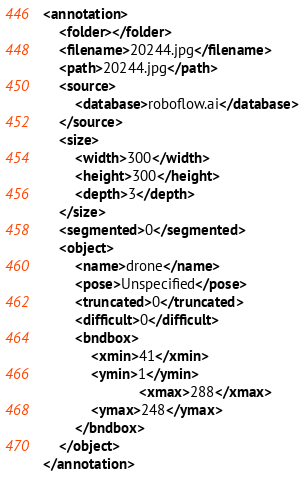Convert code to text. <code><loc_0><loc_0><loc_500><loc_500><_XML_><annotation>
	<folder></folder>
	<filename>20244.jpg</filename>
	<path>20244.jpg</path>
	<source>
		<database>roboflow.ai</database>
	</source>
	<size>
		<width>300</width>
		<height>300</height>
		<depth>3</depth>
	</size>
	<segmented>0</segmented>
	<object>
		<name>drone</name>
		<pose>Unspecified</pose>
		<truncated>0</truncated>
		<difficult>0</difficult>
		<bndbox>
			<xmin>41</xmin>
			<ymin>1</ymin>
                        <xmax>288</xmax>
			<ymax>248</ymax>
		</bndbox>
	</object>
</annotation>
</code> 